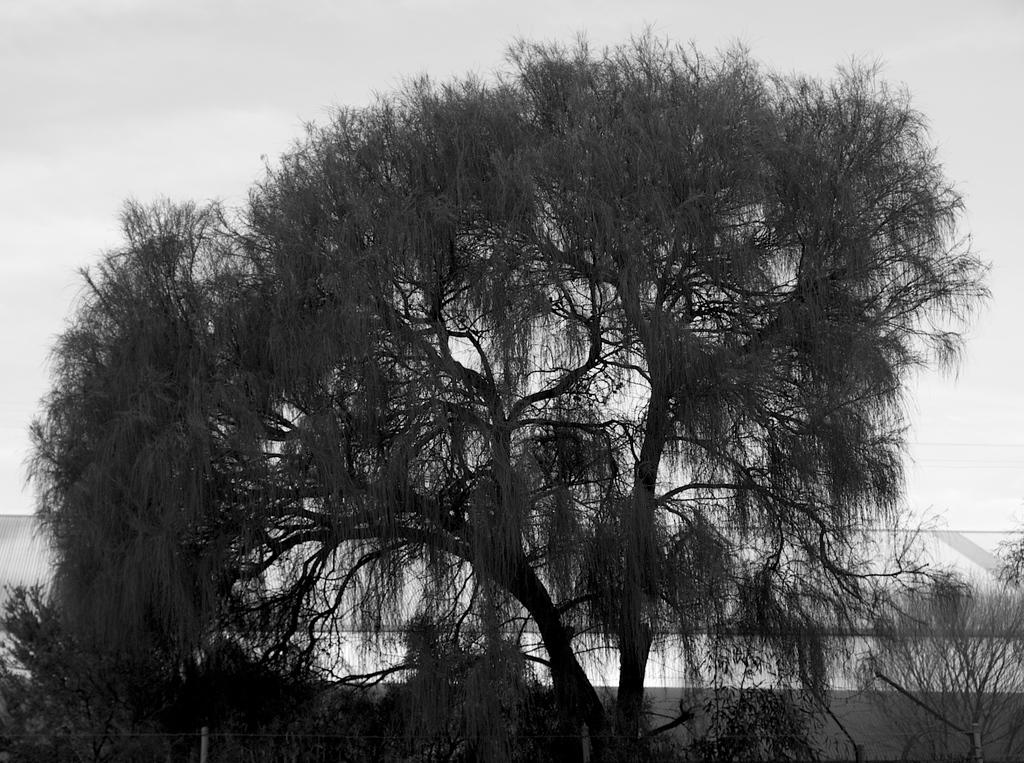What is the color scheme of the image? The image is black and white. What type of vegetation can be seen in the image? There are trees and plants in the image. What kind of barrier is present in the image? There is a fence in the image. What natural element is visible in the image? Water is visible in the image. What part of the natural environment is visible in the image? The sky is visible in the image. Can you see any wings on the trees in the image? There are no wings visible on the trees in the image. Is there a chessboard in the image? There is no chessboard present in the image. 